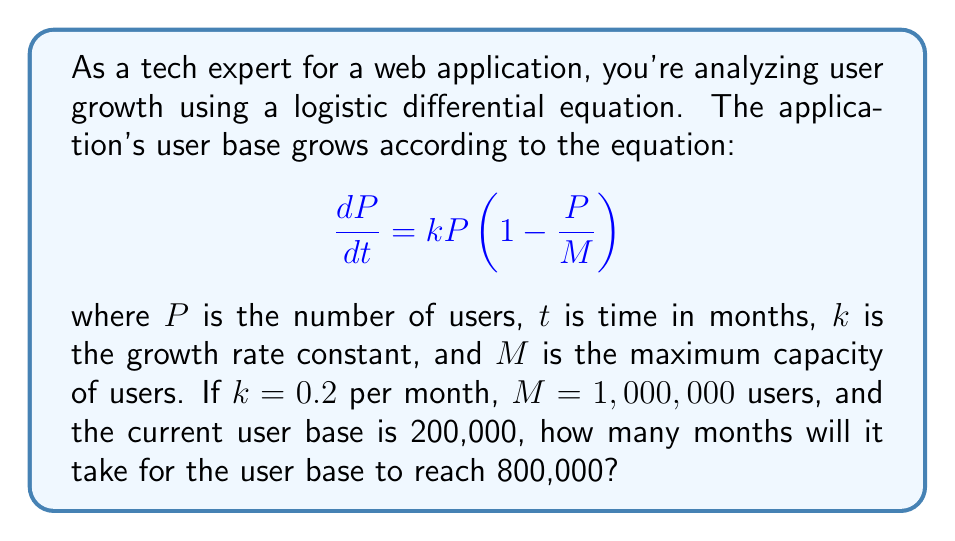Help me with this question. To solve this problem, we need to use the solution to the logistic differential equation:

$$P(t) = \frac{M}{1 + (\frac{M}{P_0} - 1)e^{-kt}}$$

Where $P_0$ is the initial population (in this case, initial number of users).

Let's plug in the known values:
$M = 1,000,000$
$k = 0.2$
$P_0 = 200,000$

We want to find $t$ when $P(t) = 800,000$.

1) Substitute these values into the equation:

   $$800,000 = \frac{1,000,000}{1 + (\frac{1,000,000}{200,000} - 1)e^{-0.2t}}$$

2) Simplify:

   $$800,000 = \frac{1,000,000}{1 + 4e^{-0.2t}}$$

3) Multiply both sides by $(1 + 4e^{-0.2t})$:

   $$800,000(1 + 4e^{-0.2t}) = 1,000,000$$

4) Distribute on the left side:

   $$800,000 + 3,200,000e^{-0.2t} = 1,000,000$$

5) Subtract 800,000 from both sides:

   $$3,200,000e^{-0.2t} = 200,000$$

6) Divide both sides by 3,200,000:

   $$e^{-0.2t} = \frac{1}{16}$$

7) Take the natural log of both sides:

   $$-0.2t = \ln(\frac{1}{16}) = -\ln(16)$$

8) Divide both sides by -0.2:

   $$t = \frac{\ln(16)}{0.2} \approx 13.86$$

Therefore, it will take approximately 13.86 months for the user base to reach 800,000.
Answer: It will take approximately 13.86 months for the user base to reach 800,000. 